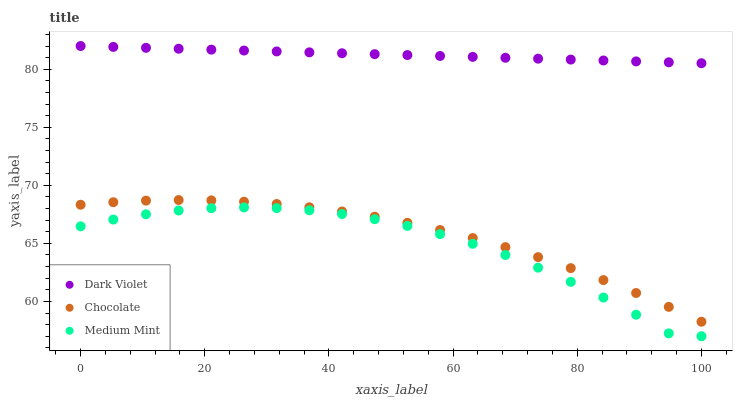Does Medium Mint have the minimum area under the curve?
Answer yes or no. Yes. Does Dark Violet have the maximum area under the curve?
Answer yes or no. Yes. Does Chocolate have the minimum area under the curve?
Answer yes or no. No. Does Chocolate have the maximum area under the curve?
Answer yes or no. No. Is Dark Violet the smoothest?
Answer yes or no. Yes. Is Medium Mint the roughest?
Answer yes or no. Yes. Is Chocolate the smoothest?
Answer yes or no. No. Is Chocolate the roughest?
Answer yes or no. No. Does Medium Mint have the lowest value?
Answer yes or no. Yes. Does Chocolate have the lowest value?
Answer yes or no. No. Does Dark Violet have the highest value?
Answer yes or no. Yes. Does Chocolate have the highest value?
Answer yes or no. No. Is Medium Mint less than Dark Violet?
Answer yes or no. Yes. Is Dark Violet greater than Chocolate?
Answer yes or no. Yes. Does Medium Mint intersect Dark Violet?
Answer yes or no. No. 